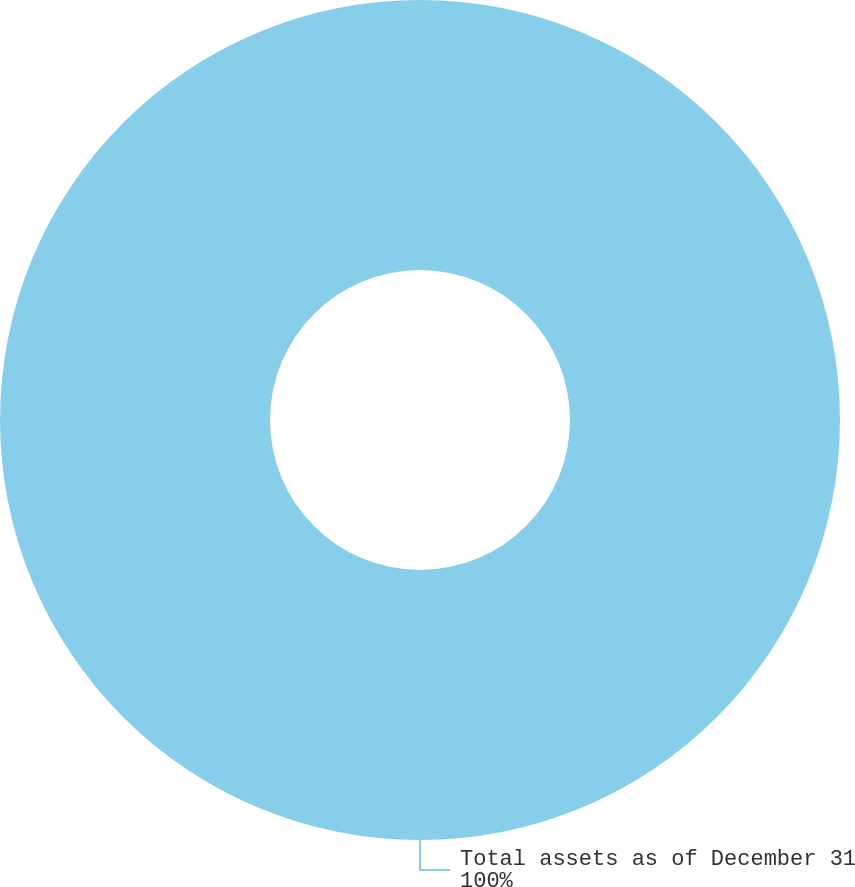Convert chart. <chart><loc_0><loc_0><loc_500><loc_500><pie_chart><fcel>Total assets as of December 31<nl><fcel>100.0%<nl></chart> 